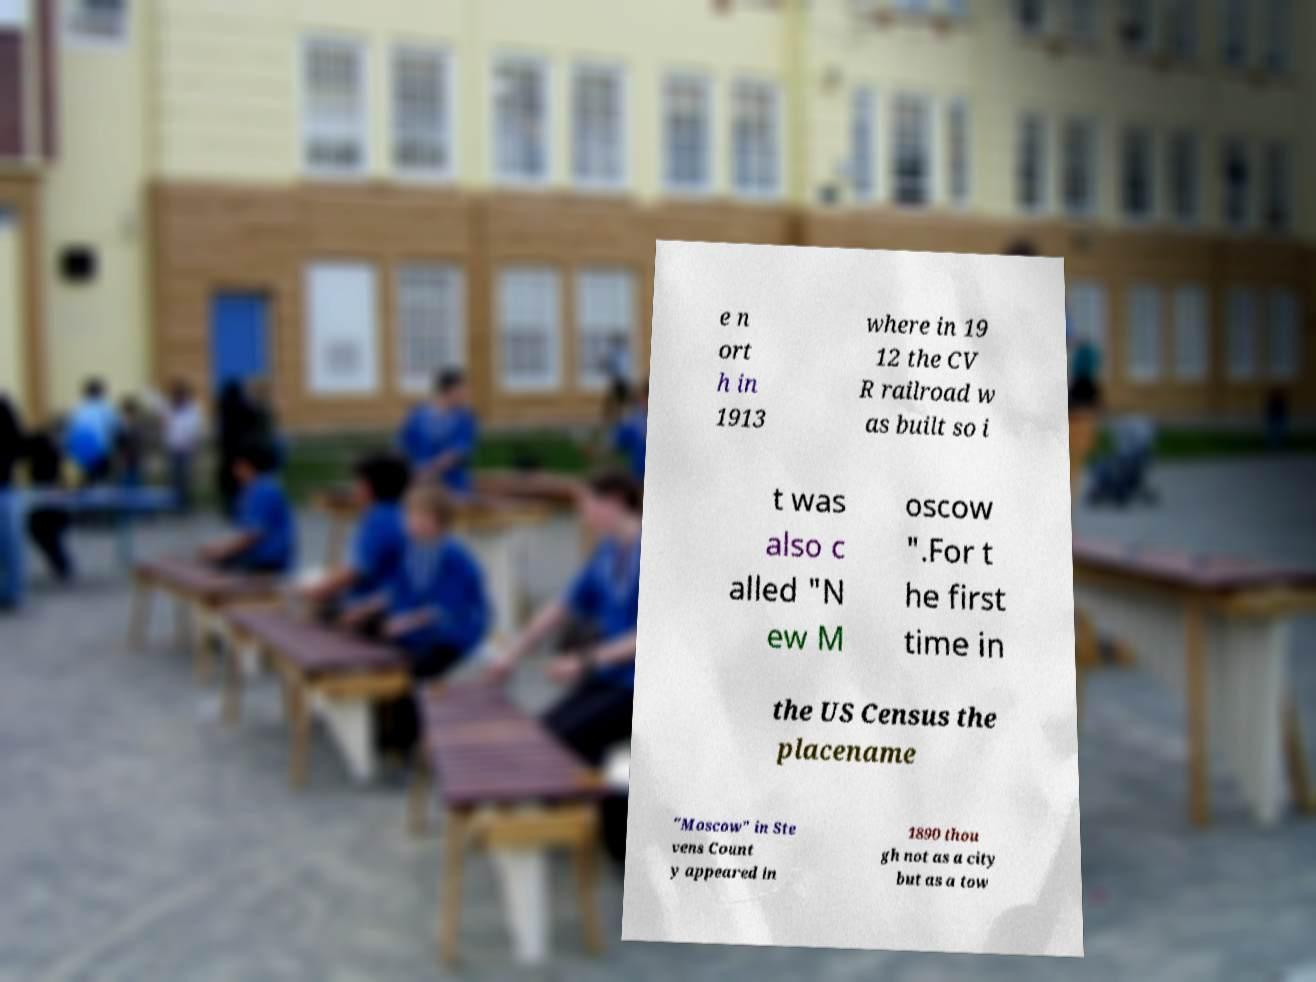Could you assist in decoding the text presented in this image and type it out clearly? e n ort h in 1913 where in 19 12 the CV R railroad w as built so i t was also c alled "N ew M oscow ".For t he first time in the US Census the placename "Moscow" in Ste vens Count y appeared in 1890 thou gh not as a city but as a tow 